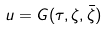Convert formula to latex. <formula><loc_0><loc_0><loc_500><loc_500>u = G ( \tau , \zeta , \bar { \zeta } )</formula> 